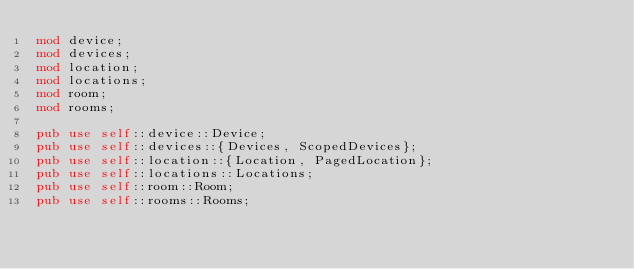<code> <loc_0><loc_0><loc_500><loc_500><_Rust_>mod device;
mod devices;
mod location;
mod locations;
mod room;
mod rooms;

pub use self::device::Device;
pub use self::devices::{Devices, ScopedDevices};
pub use self::location::{Location, PagedLocation};
pub use self::locations::Locations;
pub use self::room::Room;
pub use self::rooms::Rooms;
</code> 